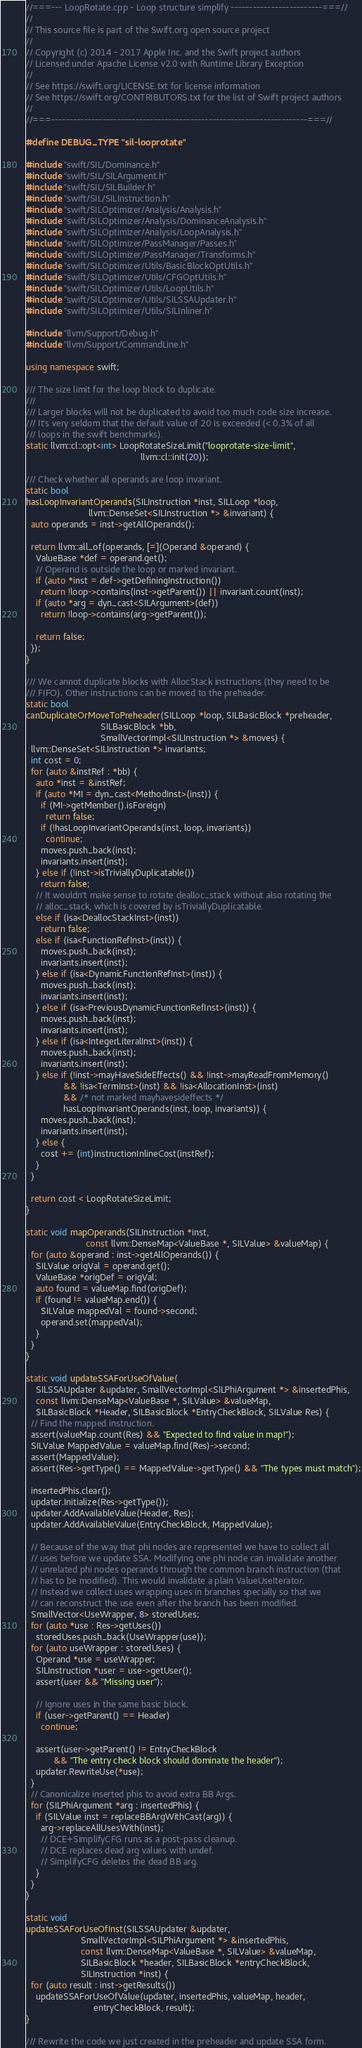Convert code to text. <code><loc_0><loc_0><loc_500><loc_500><_C++_>//===--- LoopRotate.cpp - Loop structure simplify -------------------------===//
//
// This source file is part of the Swift.org open source project
//
// Copyright (c) 2014 - 2017 Apple Inc. and the Swift project authors
// Licensed under Apache License v2.0 with Runtime Library Exception
//
// See https://swift.org/LICENSE.txt for license information
// See https://swift.org/CONTRIBUTORS.txt for the list of Swift project authors
//
//===----------------------------------------------------------------------===//

#define DEBUG_TYPE "sil-looprotate"

#include "swift/SIL/Dominance.h"
#include "swift/SIL/SILArgument.h"
#include "swift/SIL/SILBuilder.h"
#include "swift/SIL/SILInstruction.h"
#include "swift/SILOptimizer/Analysis/Analysis.h"
#include "swift/SILOptimizer/Analysis/DominanceAnalysis.h"
#include "swift/SILOptimizer/Analysis/LoopAnalysis.h"
#include "swift/SILOptimizer/PassManager/Passes.h"
#include "swift/SILOptimizer/PassManager/Transforms.h"
#include "swift/SILOptimizer/Utils/BasicBlockOptUtils.h"
#include "swift/SILOptimizer/Utils/CFGOptUtils.h"
#include "swift/SILOptimizer/Utils/LoopUtils.h"
#include "swift/SILOptimizer/Utils/SILSSAUpdater.h"
#include "swift/SILOptimizer/Utils/SILInliner.h"

#include "llvm/Support/Debug.h"
#include "llvm/Support/CommandLine.h"

using namespace swift;

/// The size limit for the loop block to duplicate.
///
/// Larger blocks will not be duplicated to avoid too much code size increase.
/// It's very seldom that the default value of 20 is exceeded (< 0.3% of all
/// loops in the swift benchmarks).
static llvm::cl::opt<int> LoopRotateSizeLimit("looprotate-size-limit",
                                              llvm::cl::init(20));

/// Check whether all operands are loop invariant.
static bool
hasLoopInvariantOperands(SILInstruction *inst, SILLoop *loop,
                         llvm::DenseSet<SILInstruction *> &invariant) {
  auto operands = inst->getAllOperands();

  return llvm::all_of(operands, [=](Operand &operand) {
    ValueBase *def = operand.get();
    // Operand is outside the loop or marked invariant.
    if (auto *inst = def->getDefiningInstruction())
      return !loop->contains(inst->getParent()) || invariant.count(inst);
    if (auto *arg = dyn_cast<SILArgument>(def))
      return !loop->contains(arg->getParent());

    return false;
  });
}

/// We cannot duplicate blocks with AllocStack instructions (they need to be
/// FIFO). Other instructions can be moved to the preheader.
static bool
canDuplicateOrMoveToPreheader(SILLoop *loop, SILBasicBlock *preheader,
                              SILBasicBlock *bb,
                              SmallVectorImpl<SILInstruction *> &moves) {
  llvm::DenseSet<SILInstruction *> invariants;
  int cost = 0;
  for (auto &instRef : *bb) {
    auto *inst = &instRef;
    if (auto *MI = dyn_cast<MethodInst>(inst)) {
      if (MI->getMember().isForeign)
        return false;
      if (!hasLoopInvariantOperands(inst, loop, invariants))
        continue;
      moves.push_back(inst);
      invariants.insert(inst);
    } else if (!inst->isTriviallyDuplicatable())
      return false;
    // It wouldn't make sense to rotate dealloc_stack without also rotating the
    // alloc_stack, which is covered by isTriviallyDuplicatable.
    else if (isa<DeallocStackInst>(inst))
      return false;
    else if (isa<FunctionRefInst>(inst)) {
      moves.push_back(inst);
      invariants.insert(inst);
    } else if (isa<DynamicFunctionRefInst>(inst)) {
      moves.push_back(inst);
      invariants.insert(inst);
    } else if (isa<PreviousDynamicFunctionRefInst>(inst)) {
      moves.push_back(inst);
      invariants.insert(inst);
    } else if (isa<IntegerLiteralInst>(inst)) {
      moves.push_back(inst);
      invariants.insert(inst);
    } else if (!inst->mayHaveSideEffects() && !inst->mayReadFromMemory()
               && !isa<TermInst>(inst) && !isa<AllocationInst>(inst)
               && /* not marked mayhavesideffects */
               hasLoopInvariantOperands(inst, loop, invariants)) {
      moves.push_back(inst);
      invariants.insert(inst);
    } else {
      cost += (int)instructionInlineCost(instRef);
    }
  }

  return cost < LoopRotateSizeLimit;
}

static void mapOperands(SILInstruction *inst,
                        const llvm::DenseMap<ValueBase *, SILValue> &valueMap) {
  for (auto &operand : inst->getAllOperands()) {
    SILValue origVal = operand.get();
    ValueBase *origDef = origVal;
    auto found = valueMap.find(origDef);
    if (found != valueMap.end()) {
      SILValue mappedVal = found->second;
      operand.set(mappedVal);
    }
  }
}

static void updateSSAForUseOfValue(
    SILSSAUpdater &updater, SmallVectorImpl<SILPhiArgument *> &insertedPhis,
    const llvm::DenseMap<ValueBase *, SILValue> &valueMap,
    SILBasicBlock *Header, SILBasicBlock *EntryCheckBlock, SILValue Res) {
  // Find the mapped instruction.
  assert(valueMap.count(Res) && "Expected to find value in map!");
  SILValue MappedValue = valueMap.find(Res)->second;
  assert(MappedValue);
  assert(Res->getType() == MappedValue->getType() && "The types must match");

  insertedPhis.clear();
  updater.Initialize(Res->getType());
  updater.AddAvailableValue(Header, Res);
  updater.AddAvailableValue(EntryCheckBlock, MappedValue);

  // Because of the way that phi nodes are represented we have to collect all
  // uses before we update SSA. Modifying one phi node can invalidate another
  // unrelated phi nodes operands through the common branch instruction (that
  // has to be modified). This would invalidate a plain ValueUseIterator.
  // Instead we collect uses wrapping uses in branches specially so that we
  // can reconstruct the use even after the branch has been modified.
  SmallVector<UseWrapper, 8> storedUses;
  for (auto *use : Res->getUses())
    storedUses.push_back(UseWrapper(use));
  for (auto useWrapper : storedUses) {
    Operand *use = useWrapper;
    SILInstruction *user = use->getUser();
    assert(user && "Missing user");

    // Ignore uses in the same basic block.
    if (user->getParent() == Header)
      continue;

    assert(user->getParent() != EntryCheckBlock
           && "The entry check block should dominate the header");
    updater.RewriteUse(*use);
  }
  // Canonicalize inserted phis to avoid extra BB Args.
  for (SILPhiArgument *arg : insertedPhis) {
    if (SILValue inst = replaceBBArgWithCast(arg)) {
      arg->replaceAllUsesWith(inst);
      // DCE+SimplifyCFG runs as a post-pass cleanup.
      // DCE replaces dead arg values with undef.
      // SimplifyCFG deletes the dead BB arg.
    }
  }
}

static void
updateSSAForUseOfInst(SILSSAUpdater &updater,
                      SmallVectorImpl<SILPhiArgument *> &insertedPhis,
                      const llvm::DenseMap<ValueBase *, SILValue> &valueMap,
                      SILBasicBlock *header, SILBasicBlock *entryCheckBlock,
                      SILInstruction *inst) {
  for (auto result : inst->getResults())
    updateSSAForUseOfValue(updater, insertedPhis, valueMap, header,
                           entryCheckBlock, result);
}

/// Rewrite the code we just created in the preheader and update SSA form.</code> 